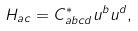<formula> <loc_0><loc_0><loc_500><loc_500>H _ { a c } = C ^ { * } _ { a b c d } u ^ { b } u ^ { d } ,</formula> 